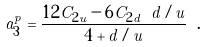<formula> <loc_0><loc_0><loc_500><loc_500>a _ { 3 } ^ { p } = \frac { 1 2 C _ { 2 u } - 6 C _ { 2 d } \ d / u } { 4 + d / u } \ .</formula> 